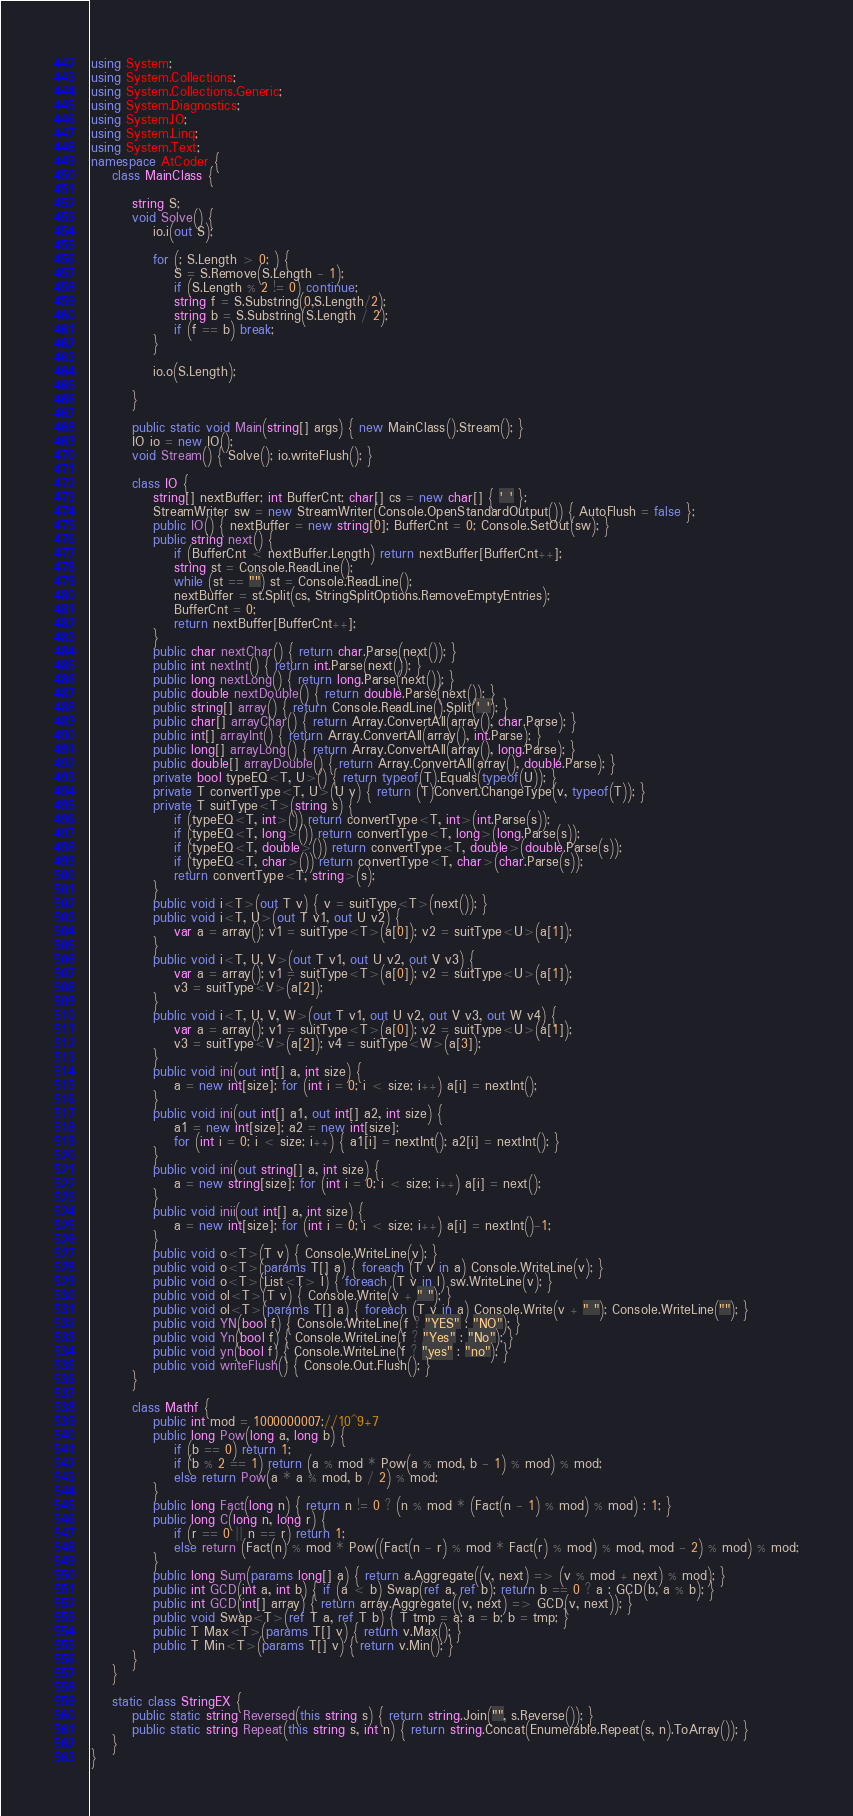<code> <loc_0><loc_0><loc_500><loc_500><_C#_>using System;
using System.Collections;
using System.Collections.Generic;
using System.Diagnostics;
using System.IO;
using System.Linq;
using System.Text;
namespace AtCoder {
    class MainClass {

        string S;
        void Solve() {
            io.i(out S);

            for (; S.Length > 0; ) {
                S = S.Remove(S.Length - 1);
                if (S.Length % 2 != 0) continue;
                string f = S.Substring(0,S.Length/2);
                string b = S.Substring(S.Length / 2);
                if (f == b) break;
            }

            io.o(S.Length);

        }
        
        public static void Main(string[] args) { new MainClass().Stream(); }
        IO io = new IO();
        void Stream() { Solve(); io.writeFlush(); }

        class IO {
            string[] nextBuffer; int BufferCnt; char[] cs = new char[] { ' ' };
            StreamWriter sw = new StreamWriter(Console.OpenStandardOutput()) { AutoFlush = false };
            public IO() { nextBuffer = new string[0]; BufferCnt = 0; Console.SetOut(sw); }
            public string next() {
                if (BufferCnt < nextBuffer.Length) return nextBuffer[BufferCnt++];
                string st = Console.ReadLine();
                while (st == "") st = Console.ReadLine();
                nextBuffer = st.Split(cs, StringSplitOptions.RemoveEmptyEntries);
                BufferCnt = 0;
                return nextBuffer[BufferCnt++];
            }
            public char nextChar() { return char.Parse(next()); }
            public int nextInt() { return int.Parse(next()); }
            public long nextLong() { return long.Parse(next()); }
            public double nextDouble() { return double.Parse(next()); }
            public string[] array() { return Console.ReadLine().Split(' '); }
            public char[] arrayChar() { return Array.ConvertAll(array(), char.Parse); }
            public int[] arrayInt() { return Array.ConvertAll(array(), int.Parse); }
            public long[] arrayLong() { return Array.ConvertAll(array(), long.Parse); }
            public double[] arrayDouble() { return Array.ConvertAll(array(), double.Parse); }
            private bool typeEQ<T, U>() { return typeof(T).Equals(typeof(U)); }
            private T convertType<T, U>(U v) { return (T)Convert.ChangeType(v, typeof(T)); }
            private T suitType<T>(string s) {
                if (typeEQ<T, int>()) return convertType<T, int>(int.Parse(s));
                if (typeEQ<T, long>()) return convertType<T, long>(long.Parse(s));
                if (typeEQ<T, double>()) return convertType<T, double>(double.Parse(s));
                if (typeEQ<T, char>()) return convertType<T, char>(char.Parse(s));
                return convertType<T, string>(s);
            }
            public void i<T>(out T v) { v = suitType<T>(next()); }
            public void i<T, U>(out T v1, out U v2) {
                var a = array(); v1 = suitType<T>(a[0]); v2 = suitType<U>(a[1]);
            }
            public void i<T, U, V>(out T v1, out U v2, out V v3) {
                var a = array(); v1 = suitType<T>(a[0]); v2 = suitType<U>(a[1]);
                v3 = suitType<V>(a[2]);
            }
            public void i<T, U, V, W>(out T v1, out U v2, out V v3, out W v4) {
                var a = array(); v1 = suitType<T>(a[0]); v2 = suitType<U>(a[1]);
                v3 = suitType<V>(a[2]); v4 = suitType<W>(a[3]);
            }
            public void ini(out int[] a, int size) {
                a = new int[size]; for (int i = 0; i < size; i++) a[i] = nextInt();
            }
            public void ini(out int[] a1, out int[] a2, int size) {
                a1 = new int[size]; a2 = new int[size];
                for (int i = 0; i < size; i++) { a1[i] = nextInt(); a2[i] = nextInt(); }
            }
            public void ini(out string[] a, int size) {
                a = new string[size]; for (int i = 0; i < size; i++) a[i] = next();
            }
            public void inii(out int[] a, int size) {
                a = new int[size]; for (int i = 0; i < size; i++) a[i] = nextInt()-1;
            }
            public void o<T>(T v) { Console.WriteLine(v); }
            public void o<T>(params T[] a) { foreach (T v in a) Console.WriteLine(v); }
            public void o<T>(List<T> l) { foreach (T v in l) sw.WriteLine(v); }
            public void ol<T>(T v) { Console.Write(v + " "); }
            public void ol<T>(params T[] a) { foreach (T v in a) Console.Write(v + " "); Console.WriteLine(""); }
            public void YN(bool f) { Console.WriteLine(f ? "YES" : "NO"); }
            public void Yn(bool f) { Console.WriteLine(f ? "Yes" : "No"); }
            public void yn(bool f) { Console.WriteLine(f ? "yes" : "no"); }
            public void writeFlush() { Console.Out.Flush(); }
        }

        class Mathf {
            public int mod = 1000000007;//10^9+7
            public long Pow(long a, long b) {
                if (b == 0) return 1;
                if (b % 2 == 1) return (a % mod * Pow(a % mod, b - 1) % mod) % mod;
                else return Pow(a * a % mod, b / 2) % mod;
            }
            public long Fact(long n) { return n != 0 ? (n % mod * (Fact(n - 1) % mod) % mod) : 1; }
            public long C(long n, long r) {
                if (r == 0 || n == r) return 1;
                else return (Fact(n) % mod * Pow((Fact(n - r) % mod * Fact(r) % mod) % mod, mod - 2) % mod) % mod;
            }
            public long Sum(params long[] a) { return a.Aggregate((v, next) => (v % mod + next) % mod); }
            public int GCD(int a, int b) { if (a < b) Swap(ref a, ref b); return b == 0 ? a : GCD(b, a % b); }
            public int GCD(int[] array) { return array.Aggregate((v, next) => GCD(v, next)); }
            public void Swap<T>(ref T a, ref T b) { T tmp = a; a = b; b = tmp; }
            public T Max<T>(params T[] v) { return v.Max(); }
            public T Min<T>(params T[] v) { return v.Min(); }
        }
    }
    
    static class StringEX {
        public static string Reversed(this string s) { return string.Join("", s.Reverse()); }
        public static string Repeat(this string s, int n) { return string.Concat(Enumerable.Repeat(s, n).ToArray()); }
    }
}</code> 